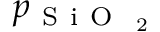<formula> <loc_0><loc_0><loc_500><loc_500>p _ { S i O _ { 2 } }</formula> 